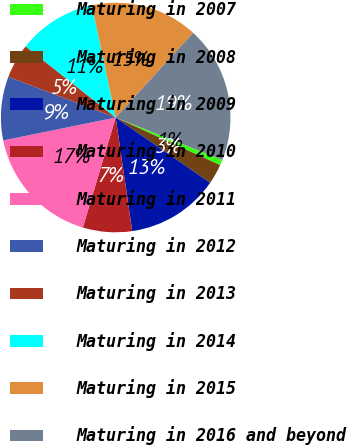Convert chart to OTSL. <chart><loc_0><loc_0><loc_500><loc_500><pie_chart><fcel>Maturing in 2007<fcel>Maturing in 2008<fcel>Maturing in 2009<fcel>Maturing in 2010<fcel>Maturing in 2011<fcel>Maturing in 2012<fcel>Maturing in 2013<fcel>Maturing in 2014<fcel>Maturing in 2015<fcel>Maturing in 2016 and beyond<nl><fcel>0.77%<fcel>2.82%<fcel>13.08%<fcel>6.92%<fcel>17.18%<fcel>8.97%<fcel>4.87%<fcel>11.03%<fcel>15.13%<fcel>19.23%<nl></chart> 